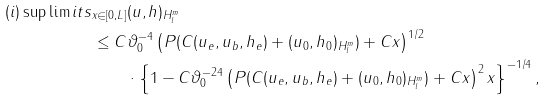Convert formula to latex. <formula><loc_0><loc_0><loc_500><loc_500>( i ) \sup \lim i t s _ { x \in [ 0 , L ] } & \| ( u , h ) \| _ { H ^ { m } _ { l } } \\ \leq C & \vartheta _ { 0 } ^ { - 4 } \left ( P ( C ( u _ { e } , u _ { b } , h _ { e } ) + \| ( u _ { 0 } , h _ { 0 } ) \| _ { H ^ { m } _ { l } } ) + C x \right ) ^ { 1 / 2 } \\ & \cdot \left \{ 1 - C \vartheta _ { 0 } ^ { - 2 4 } \left ( P ( C ( u _ { e } , u _ { b } , h _ { e } ) + \| ( u _ { 0 } , h _ { 0 } ) \| _ { H ^ { m } _ { l } } ) + C x \right ) ^ { 2 } x \right \} ^ { - 1 / 4 } ,</formula> 